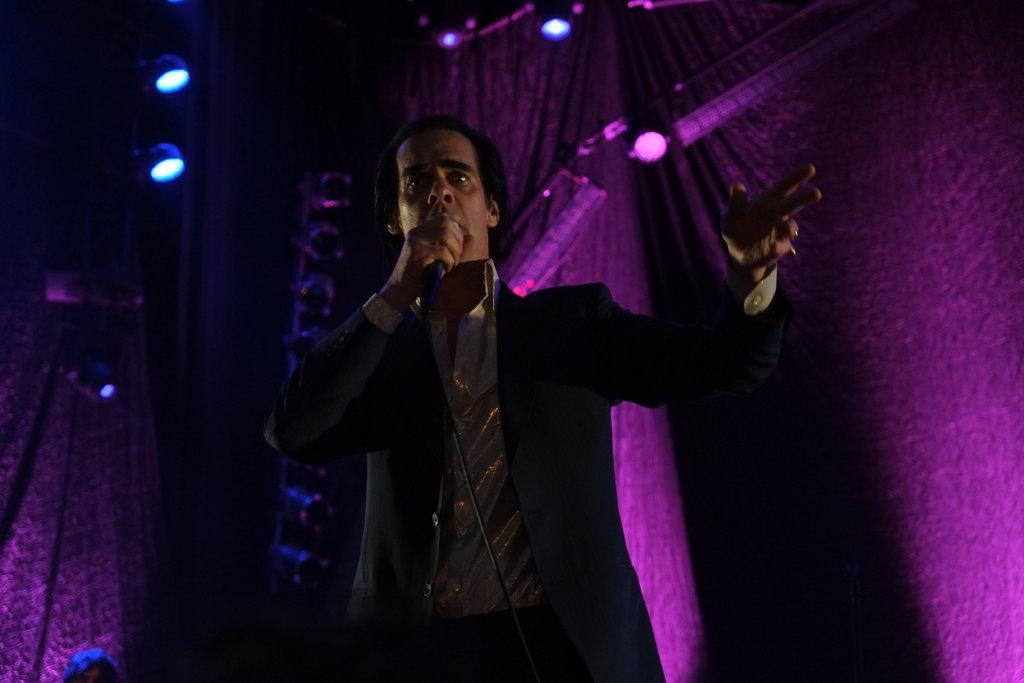How would you summarize this image in a sentence or two? In this picture we can see a man, he is speaking with the help of microphone, in the background we can find few lights and curtains. 